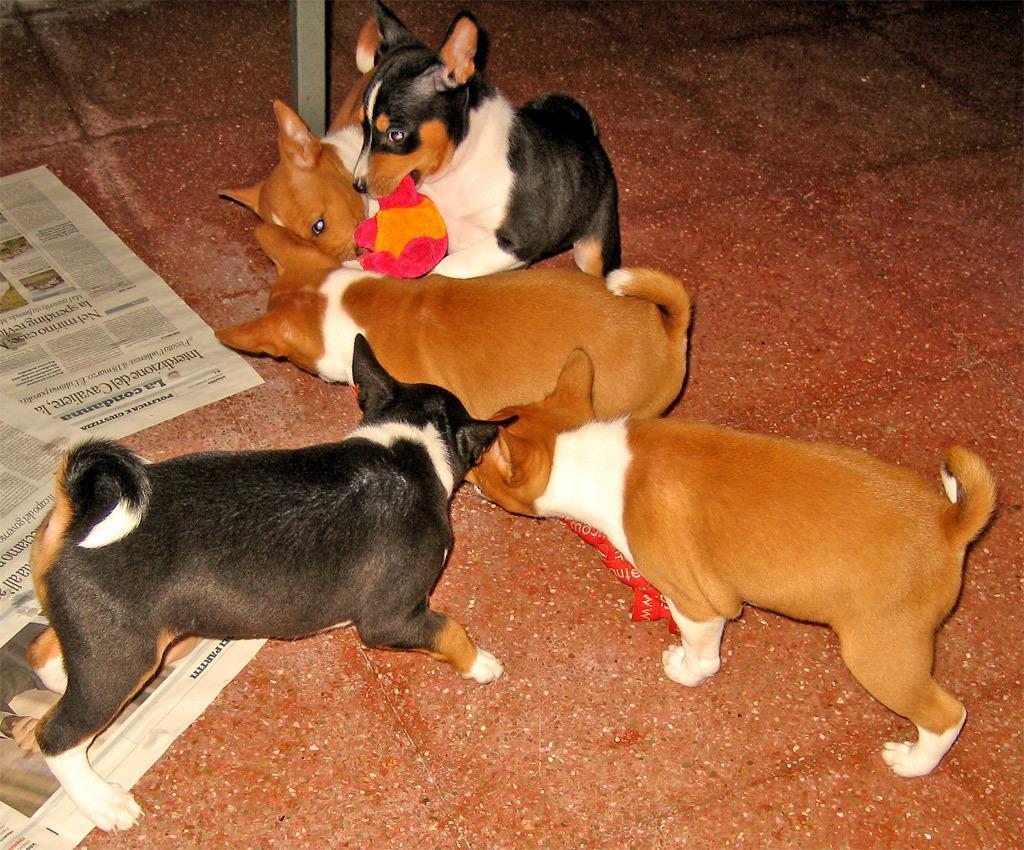Can you describe this image briefly? In the center of the image we can see dogs on the floor. On the left side of the image we can see news papers. In the background there is pole and floor. 